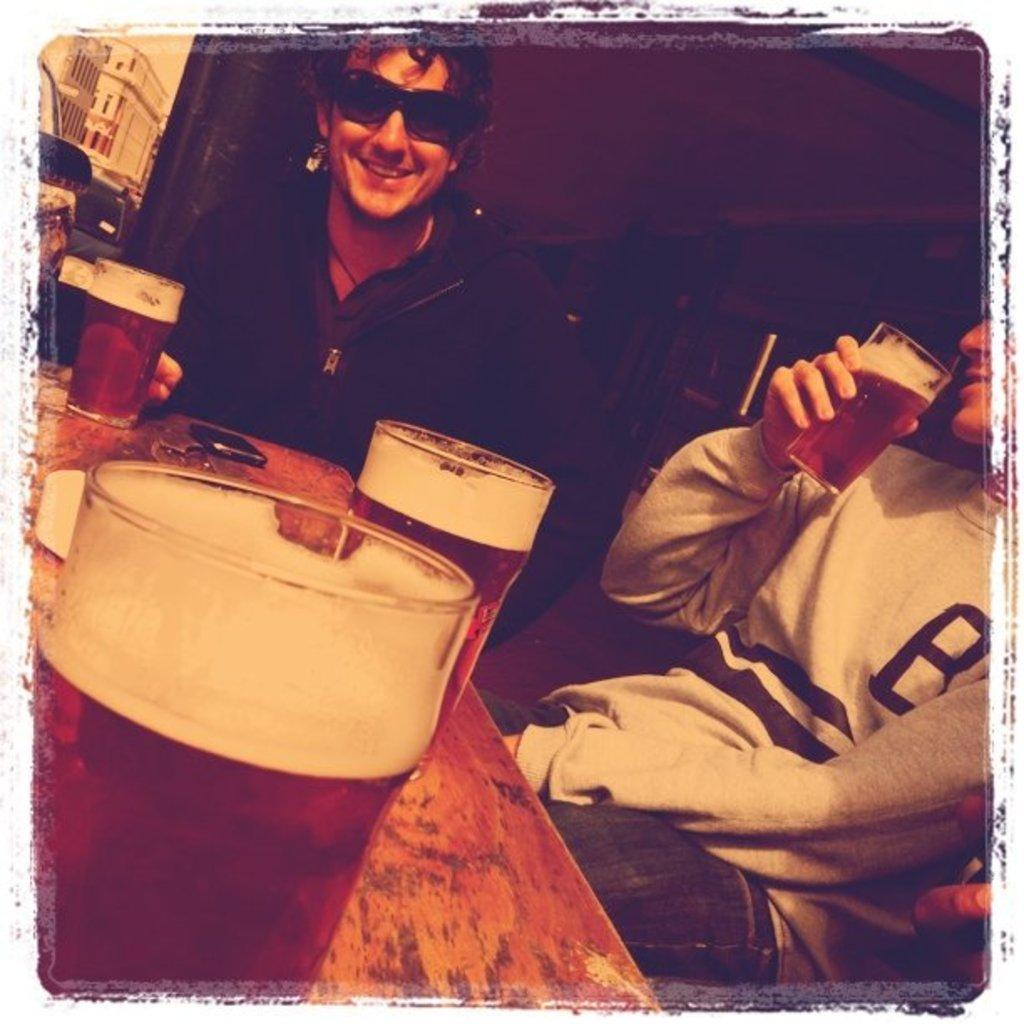How many people are in the image? There are two people in the image. What are the two people doing in the image? The two people are sitting at a table. What can be seen on the table in the image? There are three glasses filled with beer on the table. What type of insurance policy are the two people discussing in the image? There is no indication in the image that the two people are discussing insurance policies. 